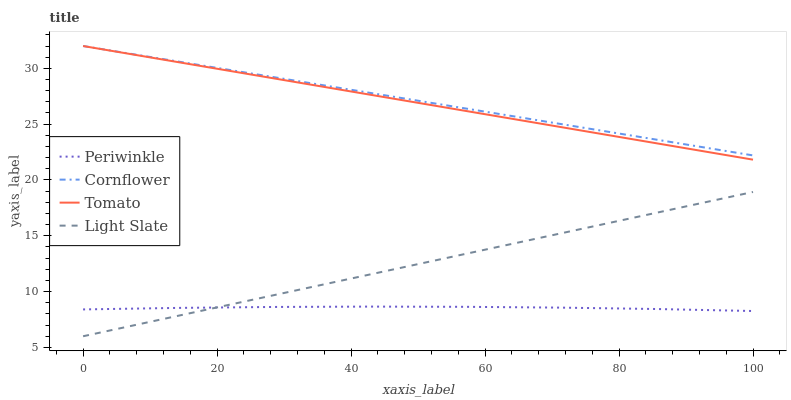Does Periwinkle have the minimum area under the curve?
Answer yes or no. Yes. Does Cornflower have the maximum area under the curve?
Answer yes or no. Yes. Does Cornflower have the minimum area under the curve?
Answer yes or no. No. Does Periwinkle have the maximum area under the curve?
Answer yes or no. No. Is Light Slate the smoothest?
Answer yes or no. Yes. Is Periwinkle the roughest?
Answer yes or no. Yes. Is Cornflower the smoothest?
Answer yes or no. No. Is Cornflower the roughest?
Answer yes or no. No. Does Light Slate have the lowest value?
Answer yes or no. Yes. Does Periwinkle have the lowest value?
Answer yes or no. No. Does Cornflower have the highest value?
Answer yes or no. Yes. Does Periwinkle have the highest value?
Answer yes or no. No. Is Light Slate less than Cornflower?
Answer yes or no. Yes. Is Cornflower greater than Light Slate?
Answer yes or no. Yes. Does Periwinkle intersect Light Slate?
Answer yes or no. Yes. Is Periwinkle less than Light Slate?
Answer yes or no. No. Is Periwinkle greater than Light Slate?
Answer yes or no. No. Does Light Slate intersect Cornflower?
Answer yes or no. No. 